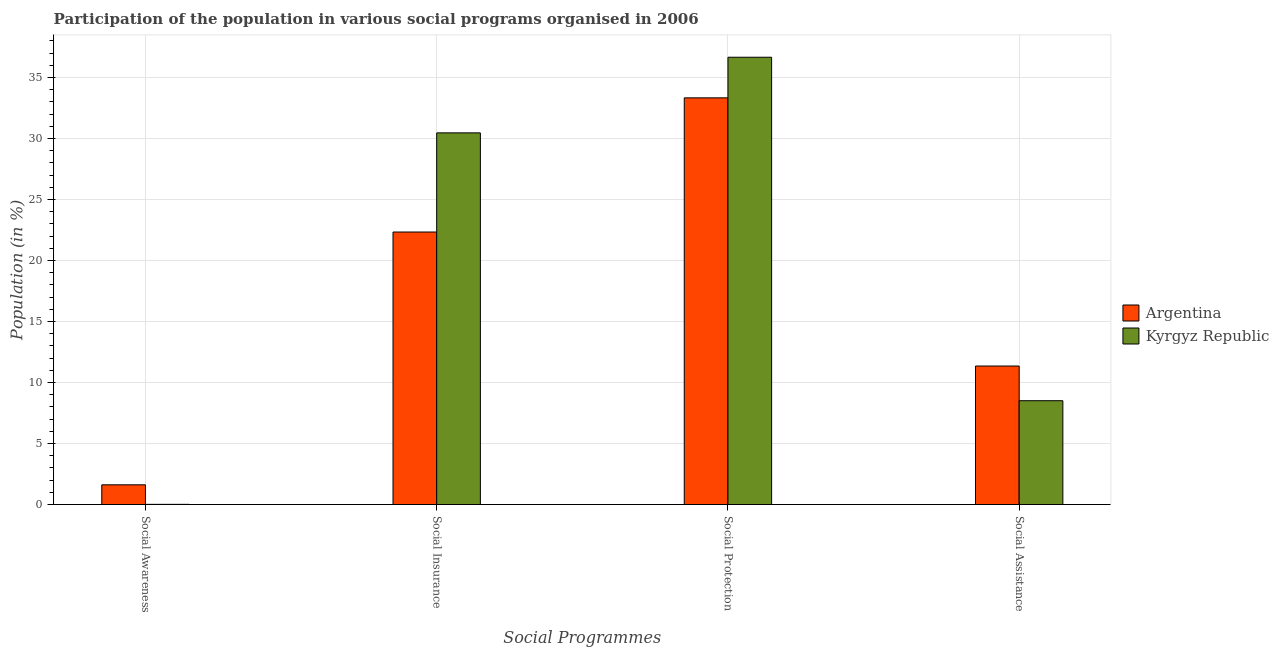Are the number of bars per tick equal to the number of legend labels?
Your response must be concise. Yes. How many bars are there on the 1st tick from the left?
Provide a succinct answer. 2. What is the label of the 4th group of bars from the left?
Your answer should be compact. Social Assistance. What is the participation of population in social awareness programs in Argentina?
Your answer should be very brief. 1.62. Across all countries, what is the maximum participation of population in social assistance programs?
Offer a very short reply. 11.35. Across all countries, what is the minimum participation of population in social insurance programs?
Offer a terse response. 22.34. In which country was the participation of population in social insurance programs maximum?
Ensure brevity in your answer.  Kyrgyz Republic. In which country was the participation of population in social assistance programs minimum?
Provide a succinct answer. Kyrgyz Republic. What is the total participation of population in social protection programs in the graph?
Your response must be concise. 70. What is the difference between the participation of population in social assistance programs in Kyrgyz Republic and that in Argentina?
Ensure brevity in your answer.  -2.84. What is the difference between the participation of population in social protection programs in Kyrgyz Republic and the participation of population in social awareness programs in Argentina?
Your response must be concise. 35.05. What is the average participation of population in social awareness programs per country?
Make the answer very short. 0.82. What is the difference between the participation of population in social insurance programs and participation of population in social assistance programs in Kyrgyz Republic?
Keep it short and to the point. 21.96. What is the ratio of the participation of population in social assistance programs in Kyrgyz Republic to that in Argentina?
Keep it short and to the point. 0.75. What is the difference between the highest and the second highest participation of population in social insurance programs?
Give a very brief answer. 8.13. What is the difference between the highest and the lowest participation of population in social awareness programs?
Provide a short and direct response. 1.6. In how many countries, is the participation of population in social insurance programs greater than the average participation of population in social insurance programs taken over all countries?
Give a very brief answer. 1. Is the sum of the participation of population in social assistance programs in Kyrgyz Republic and Argentina greater than the maximum participation of population in social awareness programs across all countries?
Your answer should be very brief. Yes. Is it the case that in every country, the sum of the participation of population in social awareness programs and participation of population in social protection programs is greater than the sum of participation of population in social insurance programs and participation of population in social assistance programs?
Your answer should be compact. No. What does the 1st bar from the left in Social Insurance represents?
Keep it short and to the point. Argentina. What does the 1st bar from the right in Social Assistance represents?
Keep it short and to the point. Kyrgyz Republic. Is it the case that in every country, the sum of the participation of population in social awareness programs and participation of population in social insurance programs is greater than the participation of population in social protection programs?
Give a very brief answer. No. Are all the bars in the graph horizontal?
Your answer should be compact. No. How many countries are there in the graph?
Keep it short and to the point. 2. Are the values on the major ticks of Y-axis written in scientific E-notation?
Keep it short and to the point. No. Does the graph contain any zero values?
Give a very brief answer. No. What is the title of the graph?
Ensure brevity in your answer.  Participation of the population in various social programs organised in 2006. Does "Poland" appear as one of the legend labels in the graph?
Your answer should be compact. No. What is the label or title of the X-axis?
Offer a terse response. Social Programmes. What is the Population (in %) in Argentina in Social Awareness?
Make the answer very short. 1.62. What is the Population (in %) of Kyrgyz Republic in Social Awareness?
Your answer should be very brief. 0.02. What is the Population (in %) in Argentina in Social Insurance?
Provide a short and direct response. 22.34. What is the Population (in %) in Kyrgyz Republic in Social Insurance?
Give a very brief answer. 30.47. What is the Population (in %) in Argentina in Social Protection?
Your answer should be compact. 33.34. What is the Population (in %) in Kyrgyz Republic in Social Protection?
Provide a short and direct response. 36.66. What is the Population (in %) of Argentina in Social Assistance?
Provide a succinct answer. 11.35. What is the Population (in %) in Kyrgyz Republic in Social Assistance?
Offer a terse response. 8.51. Across all Social Programmes, what is the maximum Population (in %) of Argentina?
Keep it short and to the point. 33.34. Across all Social Programmes, what is the maximum Population (in %) of Kyrgyz Republic?
Make the answer very short. 36.66. Across all Social Programmes, what is the minimum Population (in %) in Argentina?
Offer a very short reply. 1.62. Across all Social Programmes, what is the minimum Population (in %) in Kyrgyz Republic?
Your answer should be compact. 0.02. What is the total Population (in %) of Argentina in the graph?
Provide a short and direct response. 68.64. What is the total Population (in %) in Kyrgyz Republic in the graph?
Your response must be concise. 75.66. What is the difference between the Population (in %) in Argentina in Social Awareness and that in Social Insurance?
Ensure brevity in your answer.  -20.72. What is the difference between the Population (in %) of Kyrgyz Republic in Social Awareness and that in Social Insurance?
Keep it short and to the point. -30.45. What is the difference between the Population (in %) of Argentina in Social Awareness and that in Social Protection?
Your answer should be compact. -31.72. What is the difference between the Population (in %) of Kyrgyz Republic in Social Awareness and that in Social Protection?
Make the answer very short. -36.65. What is the difference between the Population (in %) in Argentina in Social Awareness and that in Social Assistance?
Your response must be concise. -9.74. What is the difference between the Population (in %) in Kyrgyz Republic in Social Awareness and that in Social Assistance?
Give a very brief answer. -8.5. What is the difference between the Population (in %) of Argentina in Social Insurance and that in Social Protection?
Your answer should be very brief. -11. What is the difference between the Population (in %) in Kyrgyz Republic in Social Insurance and that in Social Protection?
Your response must be concise. -6.2. What is the difference between the Population (in %) in Argentina in Social Insurance and that in Social Assistance?
Your answer should be very brief. 10.98. What is the difference between the Population (in %) of Kyrgyz Republic in Social Insurance and that in Social Assistance?
Ensure brevity in your answer.  21.96. What is the difference between the Population (in %) in Argentina in Social Protection and that in Social Assistance?
Your response must be concise. 21.98. What is the difference between the Population (in %) in Kyrgyz Republic in Social Protection and that in Social Assistance?
Offer a very short reply. 28.15. What is the difference between the Population (in %) in Argentina in Social Awareness and the Population (in %) in Kyrgyz Republic in Social Insurance?
Give a very brief answer. -28.85. What is the difference between the Population (in %) in Argentina in Social Awareness and the Population (in %) in Kyrgyz Republic in Social Protection?
Make the answer very short. -35.05. What is the difference between the Population (in %) in Argentina in Social Awareness and the Population (in %) in Kyrgyz Republic in Social Assistance?
Provide a succinct answer. -6.89. What is the difference between the Population (in %) in Argentina in Social Insurance and the Population (in %) in Kyrgyz Republic in Social Protection?
Provide a short and direct response. -14.33. What is the difference between the Population (in %) of Argentina in Social Insurance and the Population (in %) of Kyrgyz Republic in Social Assistance?
Offer a terse response. 13.83. What is the difference between the Population (in %) in Argentina in Social Protection and the Population (in %) in Kyrgyz Republic in Social Assistance?
Keep it short and to the point. 24.83. What is the average Population (in %) of Argentina per Social Programmes?
Make the answer very short. 17.16. What is the average Population (in %) of Kyrgyz Republic per Social Programmes?
Make the answer very short. 18.91. What is the difference between the Population (in %) of Argentina and Population (in %) of Kyrgyz Republic in Social Awareness?
Your answer should be compact. 1.6. What is the difference between the Population (in %) of Argentina and Population (in %) of Kyrgyz Republic in Social Insurance?
Ensure brevity in your answer.  -8.13. What is the difference between the Population (in %) in Argentina and Population (in %) in Kyrgyz Republic in Social Protection?
Your response must be concise. -3.33. What is the difference between the Population (in %) in Argentina and Population (in %) in Kyrgyz Republic in Social Assistance?
Your answer should be compact. 2.84. What is the ratio of the Population (in %) of Argentina in Social Awareness to that in Social Insurance?
Your response must be concise. 0.07. What is the ratio of the Population (in %) in Argentina in Social Awareness to that in Social Protection?
Provide a short and direct response. 0.05. What is the ratio of the Population (in %) of Argentina in Social Awareness to that in Social Assistance?
Make the answer very short. 0.14. What is the ratio of the Population (in %) in Kyrgyz Republic in Social Awareness to that in Social Assistance?
Make the answer very short. 0. What is the ratio of the Population (in %) in Argentina in Social Insurance to that in Social Protection?
Your answer should be very brief. 0.67. What is the ratio of the Population (in %) of Kyrgyz Republic in Social Insurance to that in Social Protection?
Make the answer very short. 0.83. What is the ratio of the Population (in %) of Argentina in Social Insurance to that in Social Assistance?
Your response must be concise. 1.97. What is the ratio of the Population (in %) in Kyrgyz Republic in Social Insurance to that in Social Assistance?
Your response must be concise. 3.58. What is the ratio of the Population (in %) in Argentina in Social Protection to that in Social Assistance?
Offer a very short reply. 2.94. What is the ratio of the Population (in %) in Kyrgyz Republic in Social Protection to that in Social Assistance?
Provide a succinct answer. 4.31. What is the difference between the highest and the second highest Population (in %) in Argentina?
Offer a terse response. 11. What is the difference between the highest and the second highest Population (in %) of Kyrgyz Republic?
Offer a very short reply. 6.2. What is the difference between the highest and the lowest Population (in %) of Argentina?
Offer a terse response. 31.72. What is the difference between the highest and the lowest Population (in %) in Kyrgyz Republic?
Your response must be concise. 36.65. 